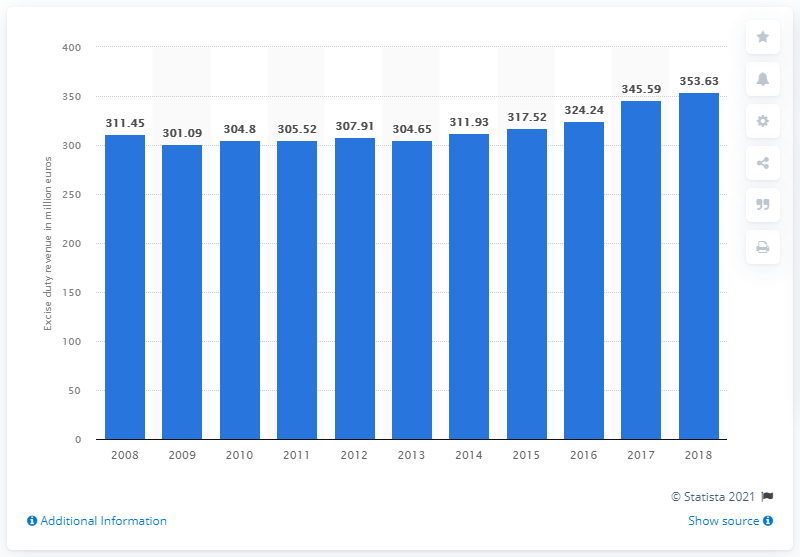Point out several critical features in this image. In 2018, the revenue generated from beer excise duty was 353.63% higher than the previous year. In 2018, the revenue collected from beer excise duty in Spain was 353.63 million euros. 